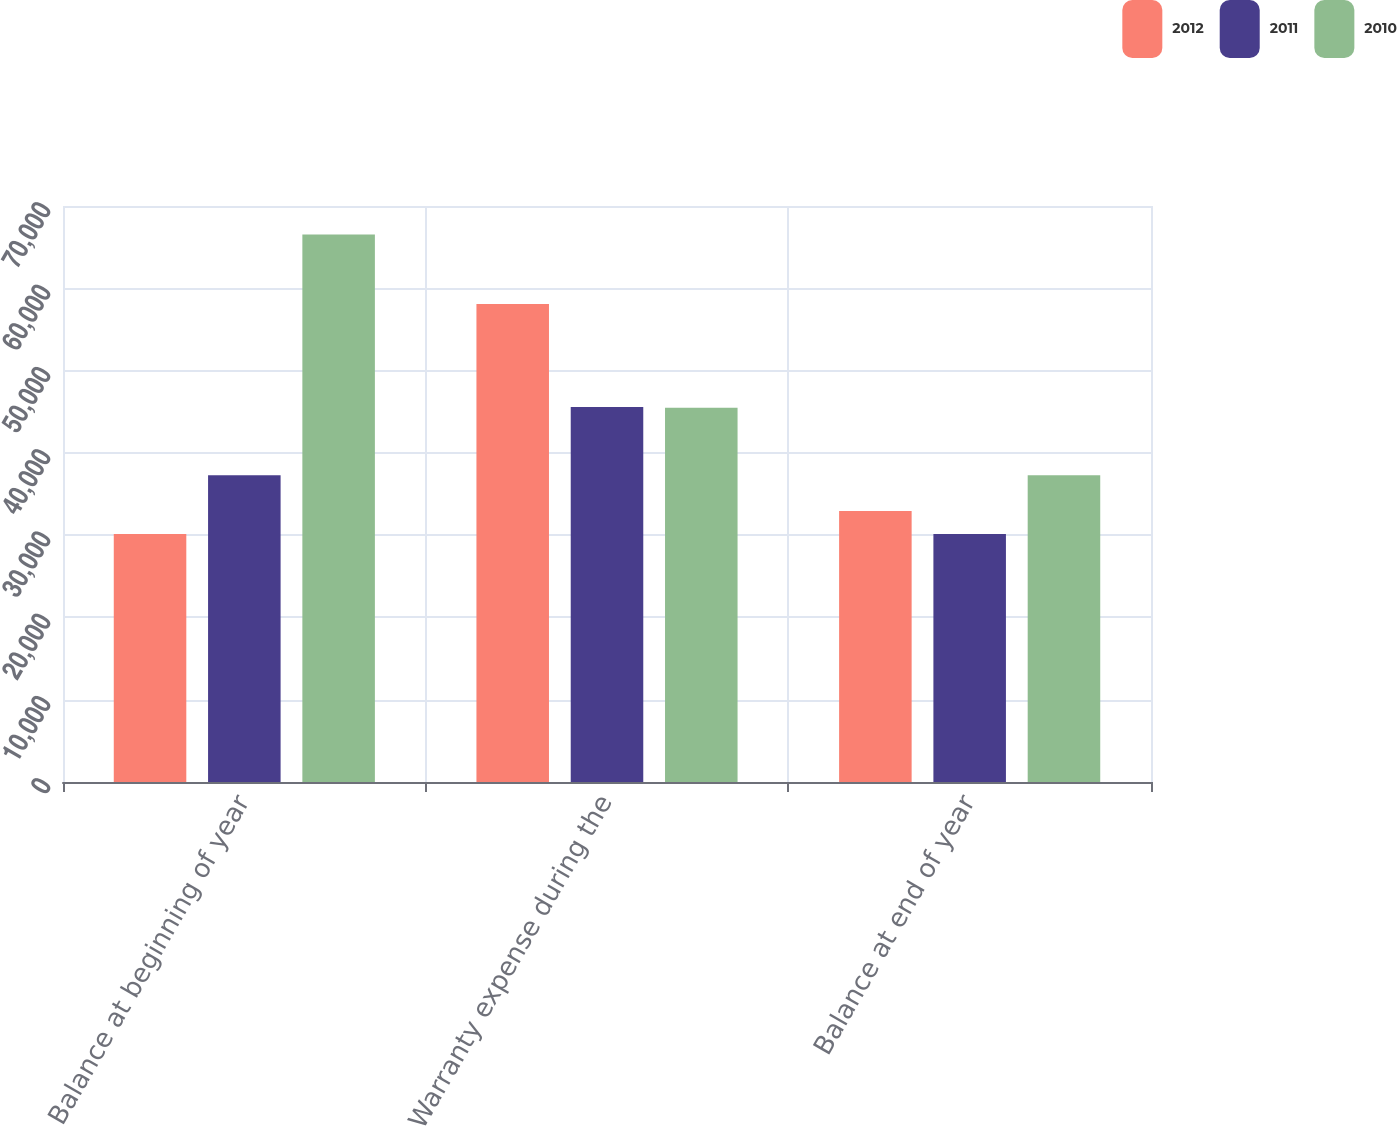<chart> <loc_0><loc_0><loc_500><loc_500><stacked_bar_chart><ecel><fcel>Balance at beginning of year<fcel>Warranty expense during the<fcel>Balance at end of year<nl><fcel>2012<fcel>30144<fcel>58100<fcel>32930<nl><fcel>2011<fcel>37265<fcel>45569<fcel>30144<nl><fcel>2010<fcel>66545<fcel>45476<fcel>37265<nl></chart> 